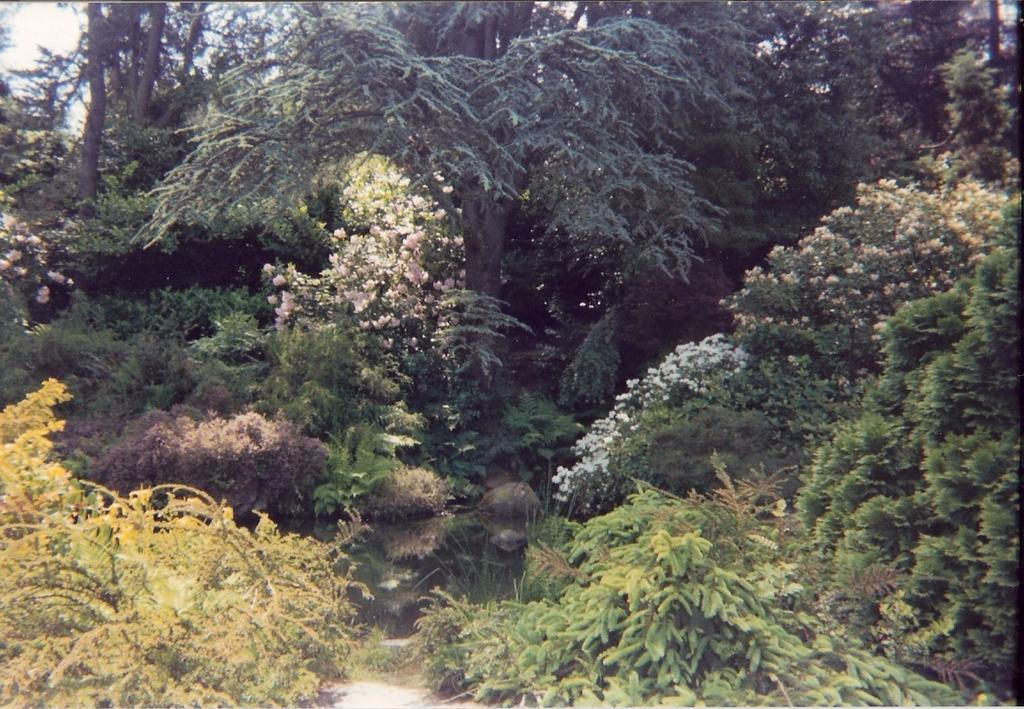What type of vegetation can be seen in the image? There are trees in the image. What other natural elements can be seen in the image? There are flowers and water visible in the image. What is visible in the background of the image? The sky is visible in the background of the image. What type of pie is being served in the image? There is no pie present in the image; it features trees, flowers, water, and the sky. 